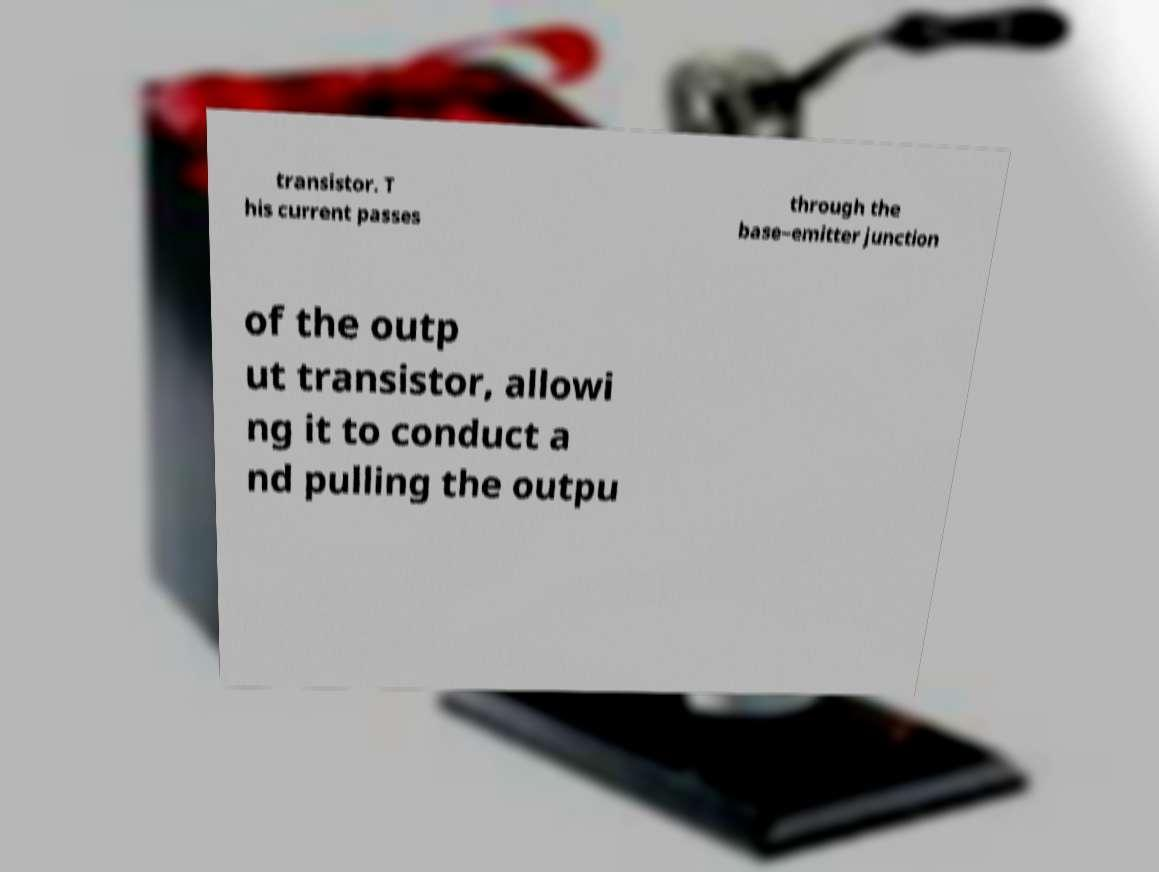I need the written content from this picture converted into text. Can you do that? transistor. T his current passes through the base–emitter junction of the outp ut transistor, allowi ng it to conduct a nd pulling the outpu 